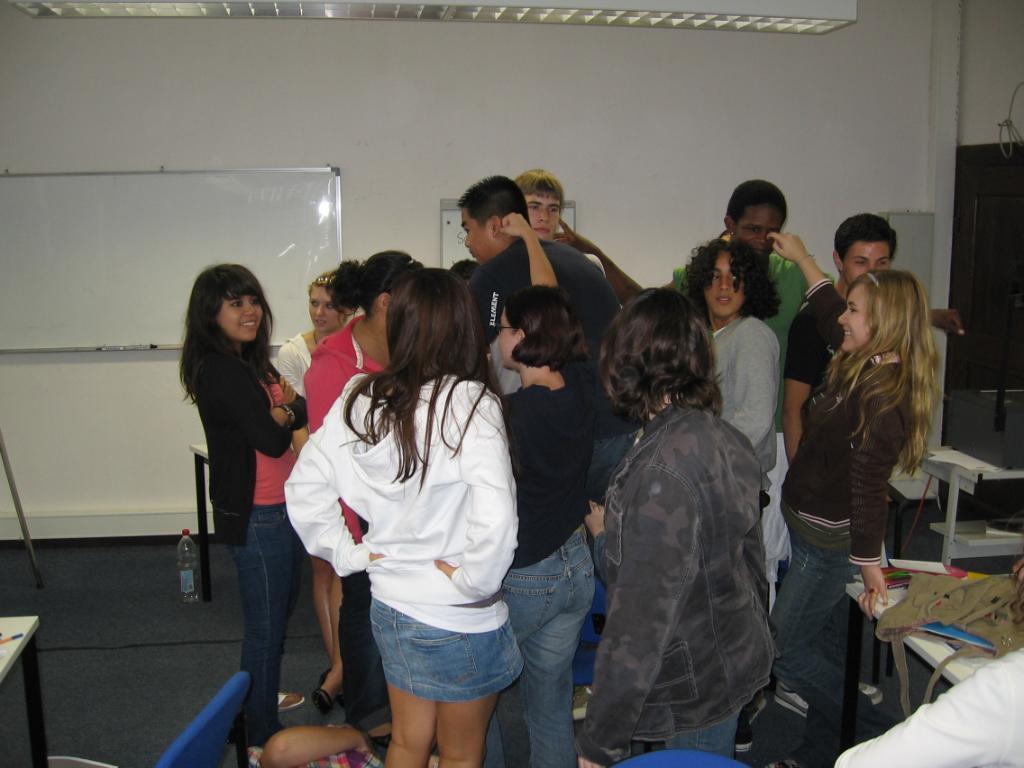Please provide a concise description of this image. Here in this picture we can see a group of people standing over a place and most of them are smiling and beside them on either side we can see tables present and on the right side we can see a bag present on the table and on the left side, on the wall we can see a white board present and at the top we can see a light present. 